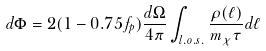Convert formula to latex. <formula><loc_0><loc_0><loc_500><loc_500>d \Phi = 2 ( 1 - 0 . 7 5 f _ { p } ) \frac { d \Omega } { 4 \pi } \int _ { l . o . s . } \frac { \rho ( \ell ) } { m _ { \chi } \tau } d \ell</formula> 